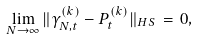Convert formula to latex. <formula><loc_0><loc_0><loc_500><loc_500>\lim _ { N \to \infty } \| \gamma _ { N , t } ^ { ( k ) } - P ^ { ( k ) } _ { t } \| _ { H S } \, = \, 0 ,</formula> 